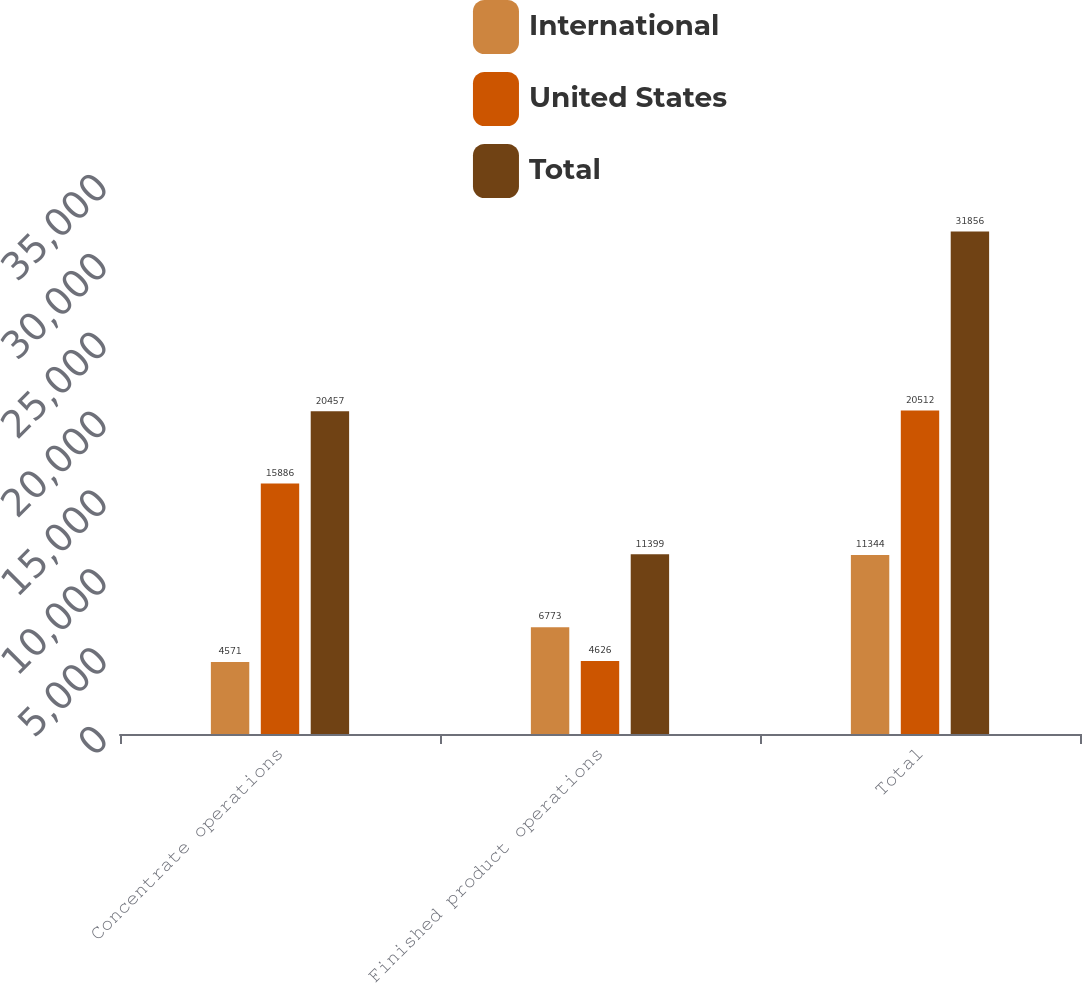<chart> <loc_0><loc_0><loc_500><loc_500><stacked_bar_chart><ecel><fcel>Concentrate operations<fcel>Finished product operations<fcel>Total<nl><fcel>International<fcel>4571<fcel>6773<fcel>11344<nl><fcel>United States<fcel>15886<fcel>4626<fcel>20512<nl><fcel>Total<fcel>20457<fcel>11399<fcel>31856<nl></chart> 